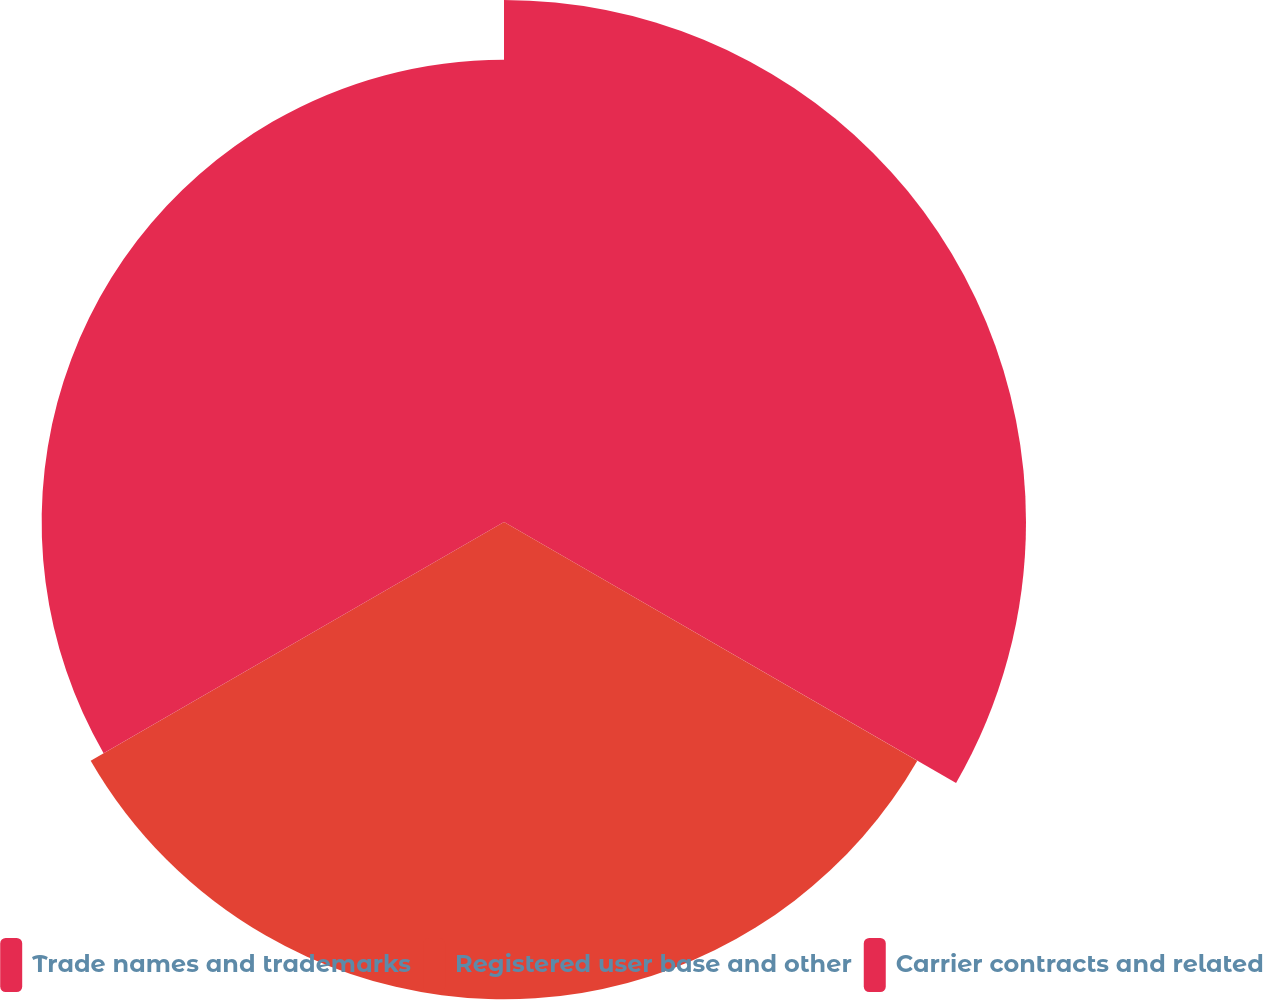Convert chart. <chart><loc_0><loc_0><loc_500><loc_500><pie_chart><fcel>Trade names and trademarks<fcel>Registered user base and other<fcel>Carrier contracts and related<nl><fcel>35.71%<fcel>32.65%<fcel>31.63%<nl></chart> 